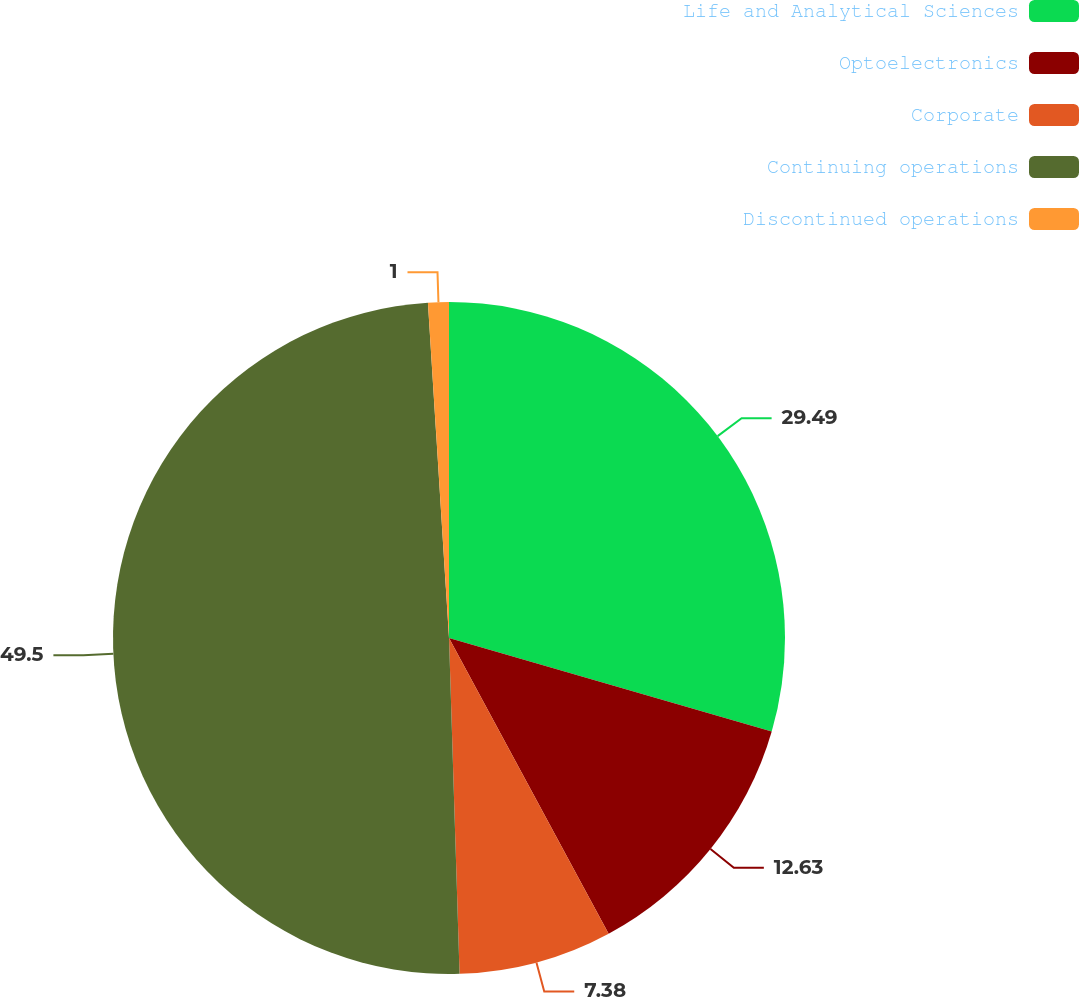Convert chart. <chart><loc_0><loc_0><loc_500><loc_500><pie_chart><fcel>Life and Analytical Sciences<fcel>Optoelectronics<fcel>Corporate<fcel>Continuing operations<fcel>Discontinued operations<nl><fcel>29.49%<fcel>12.63%<fcel>7.38%<fcel>49.5%<fcel>1.0%<nl></chart> 